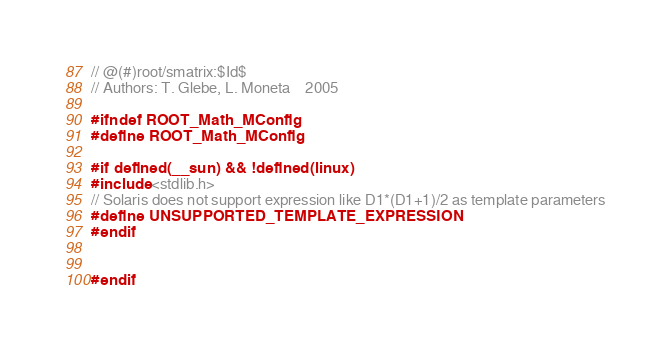Convert code to text. <code><loc_0><loc_0><loc_500><loc_500><_C_>// @(#)root/smatrix:$Id$
// Authors: T. Glebe, L. Moneta    2005

#ifndef ROOT_Math_MConfig
#define ROOT_Math_MConfig

#if defined(__sun) && !defined(linux)
#include <stdlib.h>
// Solaris does not support expression like D1*(D1+1)/2 as template parameters
#define UNSUPPORTED_TEMPLATE_EXPRESSION
#endif


#endif
</code> 